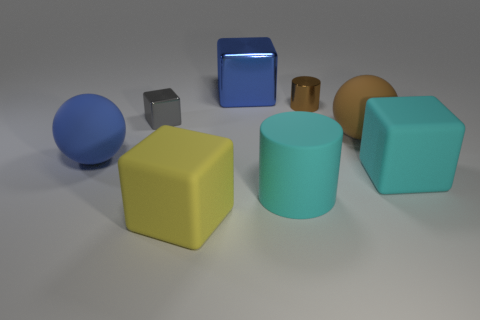Add 1 blue matte balls. How many objects exist? 9 Subtract all cylinders. How many objects are left? 6 Subtract 0 green cylinders. How many objects are left? 8 Subtract all metal cylinders. Subtract all big yellow things. How many objects are left? 6 Add 4 large matte objects. How many large matte objects are left? 9 Add 5 brown matte cylinders. How many brown matte cylinders exist? 5 